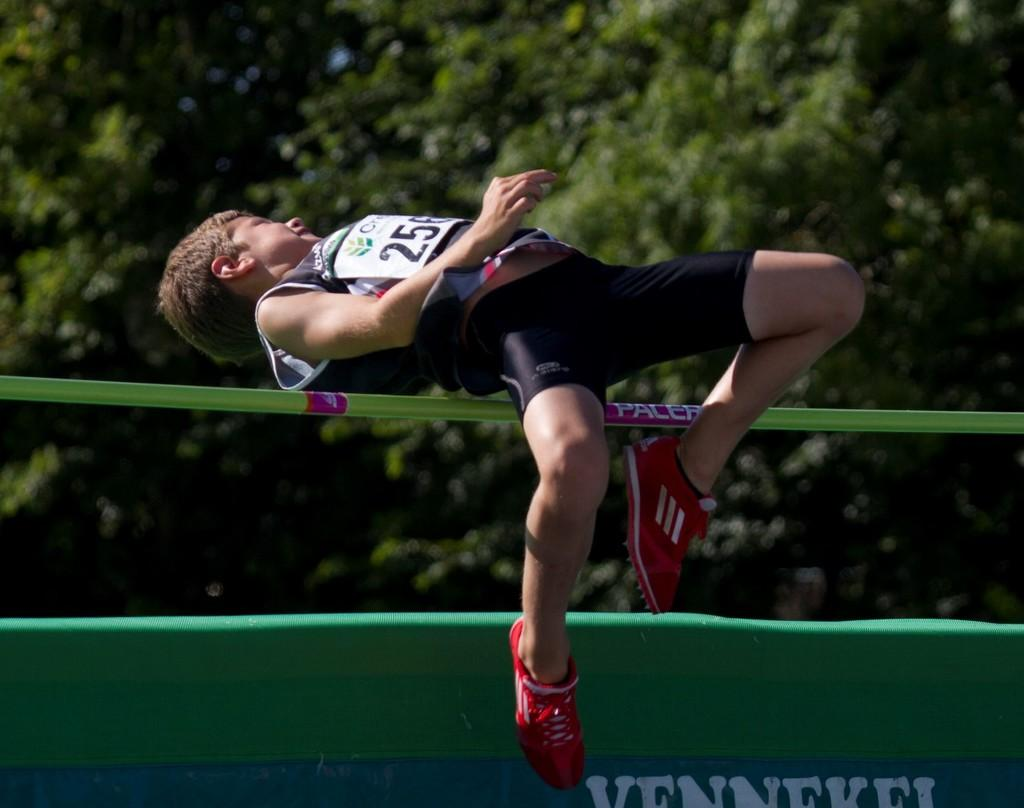<image>
Share a concise interpretation of the image provided. A man wearing the number 25 on his track suit is jumping over a pole in a track and field competition. 